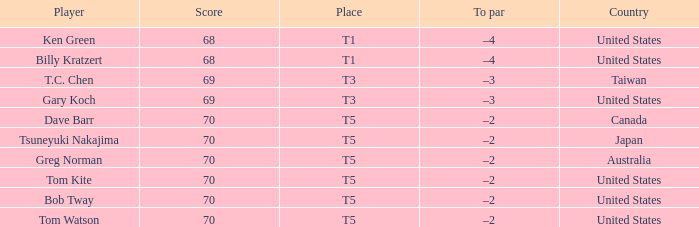What is the lowest score that Bob Tway get when he placed t5? 70.0. 